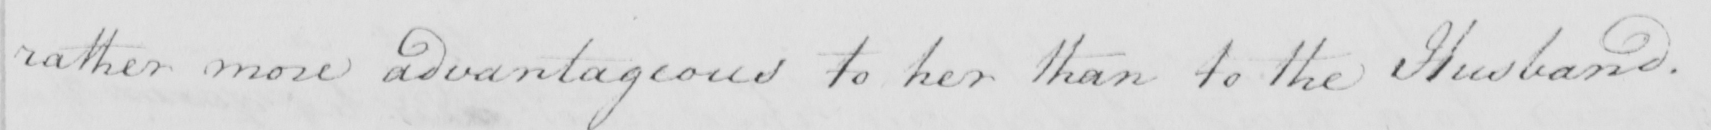Can you read and transcribe this handwriting? rather more advantageous to her than to the Husband . 